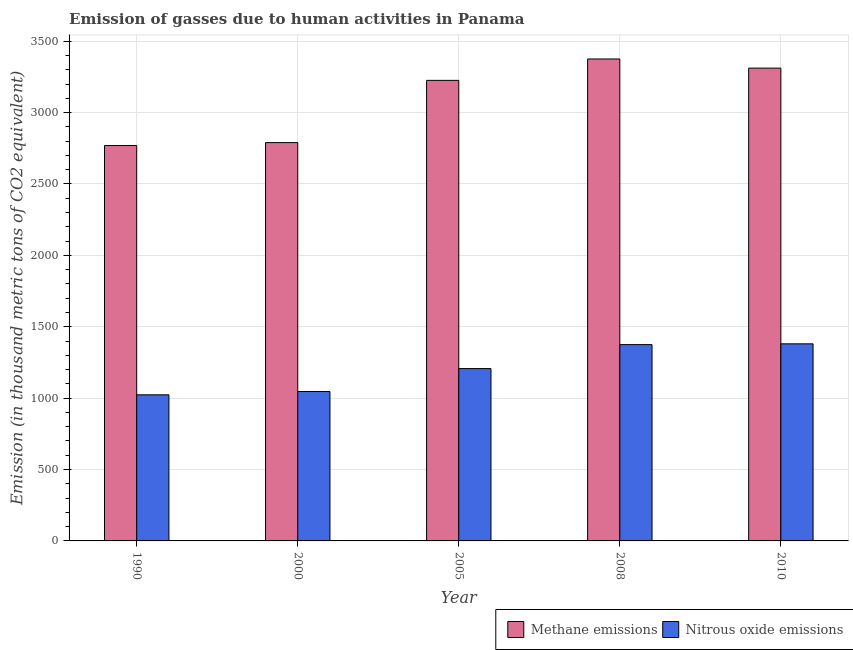What is the label of the 4th group of bars from the left?
Give a very brief answer. 2008. In how many cases, is the number of bars for a given year not equal to the number of legend labels?
Offer a terse response. 0. What is the amount of nitrous oxide emissions in 1990?
Provide a succinct answer. 1023.3. Across all years, what is the maximum amount of methane emissions?
Make the answer very short. 3375.7. Across all years, what is the minimum amount of methane emissions?
Offer a very short reply. 2769.4. In which year was the amount of methane emissions minimum?
Offer a very short reply. 1990. What is the total amount of nitrous oxide emissions in the graph?
Keep it short and to the point. 6032.2. What is the difference between the amount of nitrous oxide emissions in 2005 and that in 2010?
Your answer should be very brief. -173.3. What is the difference between the amount of methane emissions in 2000 and the amount of nitrous oxide emissions in 2010?
Your answer should be very brief. -521.7. What is the average amount of methane emissions per year?
Ensure brevity in your answer.  3094.5. In how many years, is the amount of methane emissions greater than 400 thousand metric tons?
Offer a terse response. 5. What is the ratio of the amount of nitrous oxide emissions in 2008 to that in 2010?
Your answer should be compact. 1. Is the amount of methane emissions in 2000 less than that in 2010?
Your answer should be very brief. Yes. Is the difference between the amount of methane emissions in 1990 and 2008 greater than the difference between the amount of nitrous oxide emissions in 1990 and 2008?
Offer a very short reply. No. What is the difference between the highest and the second highest amount of methane emissions?
Make the answer very short. 64.1. What is the difference between the highest and the lowest amount of nitrous oxide emissions?
Provide a short and direct response. 357.1. What does the 1st bar from the left in 2008 represents?
Ensure brevity in your answer.  Methane emissions. What does the 1st bar from the right in 2010 represents?
Offer a terse response. Nitrous oxide emissions. Are all the bars in the graph horizontal?
Give a very brief answer. No. How many years are there in the graph?
Provide a succinct answer. 5. What is the difference between two consecutive major ticks on the Y-axis?
Offer a terse response. 500. Are the values on the major ticks of Y-axis written in scientific E-notation?
Your answer should be compact. No. Does the graph contain any zero values?
Provide a short and direct response. No. Does the graph contain grids?
Make the answer very short. Yes. How many legend labels are there?
Keep it short and to the point. 2. How are the legend labels stacked?
Your response must be concise. Horizontal. What is the title of the graph?
Ensure brevity in your answer.  Emission of gasses due to human activities in Panama. What is the label or title of the Y-axis?
Offer a terse response. Emission (in thousand metric tons of CO2 equivalent). What is the Emission (in thousand metric tons of CO2 equivalent) of Methane emissions in 1990?
Offer a very short reply. 2769.4. What is the Emission (in thousand metric tons of CO2 equivalent) in Nitrous oxide emissions in 1990?
Offer a very short reply. 1023.3. What is the Emission (in thousand metric tons of CO2 equivalent) in Methane emissions in 2000?
Ensure brevity in your answer.  2789.9. What is the Emission (in thousand metric tons of CO2 equivalent) in Nitrous oxide emissions in 2000?
Offer a very short reply. 1046.4. What is the Emission (in thousand metric tons of CO2 equivalent) of Methane emissions in 2005?
Give a very brief answer. 3225.9. What is the Emission (in thousand metric tons of CO2 equivalent) of Nitrous oxide emissions in 2005?
Make the answer very short. 1207.1. What is the Emission (in thousand metric tons of CO2 equivalent) in Methane emissions in 2008?
Your answer should be very brief. 3375.7. What is the Emission (in thousand metric tons of CO2 equivalent) of Nitrous oxide emissions in 2008?
Provide a short and direct response. 1375. What is the Emission (in thousand metric tons of CO2 equivalent) of Methane emissions in 2010?
Provide a succinct answer. 3311.6. What is the Emission (in thousand metric tons of CO2 equivalent) of Nitrous oxide emissions in 2010?
Keep it short and to the point. 1380.4. Across all years, what is the maximum Emission (in thousand metric tons of CO2 equivalent) of Methane emissions?
Make the answer very short. 3375.7. Across all years, what is the maximum Emission (in thousand metric tons of CO2 equivalent) in Nitrous oxide emissions?
Your response must be concise. 1380.4. Across all years, what is the minimum Emission (in thousand metric tons of CO2 equivalent) of Methane emissions?
Your answer should be very brief. 2769.4. Across all years, what is the minimum Emission (in thousand metric tons of CO2 equivalent) in Nitrous oxide emissions?
Your answer should be very brief. 1023.3. What is the total Emission (in thousand metric tons of CO2 equivalent) in Methane emissions in the graph?
Ensure brevity in your answer.  1.55e+04. What is the total Emission (in thousand metric tons of CO2 equivalent) in Nitrous oxide emissions in the graph?
Offer a terse response. 6032.2. What is the difference between the Emission (in thousand metric tons of CO2 equivalent) of Methane emissions in 1990 and that in 2000?
Ensure brevity in your answer.  -20.5. What is the difference between the Emission (in thousand metric tons of CO2 equivalent) in Nitrous oxide emissions in 1990 and that in 2000?
Offer a terse response. -23.1. What is the difference between the Emission (in thousand metric tons of CO2 equivalent) of Methane emissions in 1990 and that in 2005?
Offer a terse response. -456.5. What is the difference between the Emission (in thousand metric tons of CO2 equivalent) of Nitrous oxide emissions in 1990 and that in 2005?
Provide a succinct answer. -183.8. What is the difference between the Emission (in thousand metric tons of CO2 equivalent) in Methane emissions in 1990 and that in 2008?
Give a very brief answer. -606.3. What is the difference between the Emission (in thousand metric tons of CO2 equivalent) of Nitrous oxide emissions in 1990 and that in 2008?
Your response must be concise. -351.7. What is the difference between the Emission (in thousand metric tons of CO2 equivalent) in Methane emissions in 1990 and that in 2010?
Offer a very short reply. -542.2. What is the difference between the Emission (in thousand metric tons of CO2 equivalent) in Nitrous oxide emissions in 1990 and that in 2010?
Provide a succinct answer. -357.1. What is the difference between the Emission (in thousand metric tons of CO2 equivalent) of Methane emissions in 2000 and that in 2005?
Provide a short and direct response. -436. What is the difference between the Emission (in thousand metric tons of CO2 equivalent) of Nitrous oxide emissions in 2000 and that in 2005?
Offer a very short reply. -160.7. What is the difference between the Emission (in thousand metric tons of CO2 equivalent) of Methane emissions in 2000 and that in 2008?
Your response must be concise. -585.8. What is the difference between the Emission (in thousand metric tons of CO2 equivalent) of Nitrous oxide emissions in 2000 and that in 2008?
Give a very brief answer. -328.6. What is the difference between the Emission (in thousand metric tons of CO2 equivalent) of Methane emissions in 2000 and that in 2010?
Offer a terse response. -521.7. What is the difference between the Emission (in thousand metric tons of CO2 equivalent) of Nitrous oxide emissions in 2000 and that in 2010?
Make the answer very short. -334. What is the difference between the Emission (in thousand metric tons of CO2 equivalent) in Methane emissions in 2005 and that in 2008?
Provide a short and direct response. -149.8. What is the difference between the Emission (in thousand metric tons of CO2 equivalent) of Nitrous oxide emissions in 2005 and that in 2008?
Offer a terse response. -167.9. What is the difference between the Emission (in thousand metric tons of CO2 equivalent) in Methane emissions in 2005 and that in 2010?
Make the answer very short. -85.7. What is the difference between the Emission (in thousand metric tons of CO2 equivalent) in Nitrous oxide emissions in 2005 and that in 2010?
Ensure brevity in your answer.  -173.3. What is the difference between the Emission (in thousand metric tons of CO2 equivalent) in Methane emissions in 2008 and that in 2010?
Provide a succinct answer. 64.1. What is the difference between the Emission (in thousand metric tons of CO2 equivalent) in Nitrous oxide emissions in 2008 and that in 2010?
Give a very brief answer. -5.4. What is the difference between the Emission (in thousand metric tons of CO2 equivalent) in Methane emissions in 1990 and the Emission (in thousand metric tons of CO2 equivalent) in Nitrous oxide emissions in 2000?
Your answer should be compact. 1723. What is the difference between the Emission (in thousand metric tons of CO2 equivalent) in Methane emissions in 1990 and the Emission (in thousand metric tons of CO2 equivalent) in Nitrous oxide emissions in 2005?
Provide a succinct answer. 1562.3. What is the difference between the Emission (in thousand metric tons of CO2 equivalent) of Methane emissions in 1990 and the Emission (in thousand metric tons of CO2 equivalent) of Nitrous oxide emissions in 2008?
Your answer should be compact. 1394.4. What is the difference between the Emission (in thousand metric tons of CO2 equivalent) of Methane emissions in 1990 and the Emission (in thousand metric tons of CO2 equivalent) of Nitrous oxide emissions in 2010?
Ensure brevity in your answer.  1389. What is the difference between the Emission (in thousand metric tons of CO2 equivalent) in Methane emissions in 2000 and the Emission (in thousand metric tons of CO2 equivalent) in Nitrous oxide emissions in 2005?
Offer a very short reply. 1582.8. What is the difference between the Emission (in thousand metric tons of CO2 equivalent) in Methane emissions in 2000 and the Emission (in thousand metric tons of CO2 equivalent) in Nitrous oxide emissions in 2008?
Offer a terse response. 1414.9. What is the difference between the Emission (in thousand metric tons of CO2 equivalent) of Methane emissions in 2000 and the Emission (in thousand metric tons of CO2 equivalent) of Nitrous oxide emissions in 2010?
Provide a short and direct response. 1409.5. What is the difference between the Emission (in thousand metric tons of CO2 equivalent) in Methane emissions in 2005 and the Emission (in thousand metric tons of CO2 equivalent) in Nitrous oxide emissions in 2008?
Provide a succinct answer. 1850.9. What is the difference between the Emission (in thousand metric tons of CO2 equivalent) of Methane emissions in 2005 and the Emission (in thousand metric tons of CO2 equivalent) of Nitrous oxide emissions in 2010?
Offer a terse response. 1845.5. What is the difference between the Emission (in thousand metric tons of CO2 equivalent) of Methane emissions in 2008 and the Emission (in thousand metric tons of CO2 equivalent) of Nitrous oxide emissions in 2010?
Your response must be concise. 1995.3. What is the average Emission (in thousand metric tons of CO2 equivalent) of Methane emissions per year?
Make the answer very short. 3094.5. What is the average Emission (in thousand metric tons of CO2 equivalent) in Nitrous oxide emissions per year?
Offer a terse response. 1206.44. In the year 1990, what is the difference between the Emission (in thousand metric tons of CO2 equivalent) in Methane emissions and Emission (in thousand metric tons of CO2 equivalent) in Nitrous oxide emissions?
Provide a succinct answer. 1746.1. In the year 2000, what is the difference between the Emission (in thousand metric tons of CO2 equivalent) of Methane emissions and Emission (in thousand metric tons of CO2 equivalent) of Nitrous oxide emissions?
Offer a terse response. 1743.5. In the year 2005, what is the difference between the Emission (in thousand metric tons of CO2 equivalent) in Methane emissions and Emission (in thousand metric tons of CO2 equivalent) in Nitrous oxide emissions?
Provide a succinct answer. 2018.8. In the year 2008, what is the difference between the Emission (in thousand metric tons of CO2 equivalent) of Methane emissions and Emission (in thousand metric tons of CO2 equivalent) of Nitrous oxide emissions?
Offer a very short reply. 2000.7. In the year 2010, what is the difference between the Emission (in thousand metric tons of CO2 equivalent) in Methane emissions and Emission (in thousand metric tons of CO2 equivalent) in Nitrous oxide emissions?
Make the answer very short. 1931.2. What is the ratio of the Emission (in thousand metric tons of CO2 equivalent) of Methane emissions in 1990 to that in 2000?
Provide a short and direct response. 0.99. What is the ratio of the Emission (in thousand metric tons of CO2 equivalent) of Nitrous oxide emissions in 1990 to that in 2000?
Give a very brief answer. 0.98. What is the ratio of the Emission (in thousand metric tons of CO2 equivalent) in Methane emissions in 1990 to that in 2005?
Provide a short and direct response. 0.86. What is the ratio of the Emission (in thousand metric tons of CO2 equivalent) in Nitrous oxide emissions in 1990 to that in 2005?
Keep it short and to the point. 0.85. What is the ratio of the Emission (in thousand metric tons of CO2 equivalent) in Methane emissions in 1990 to that in 2008?
Offer a very short reply. 0.82. What is the ratio of the Emission (in thousand metric tons of CO2 equivalent) in Nitrous oxide emissions in 1990 to that in 2008?
Ensure brevity in your answer.  0.74. What is the ratio of the Emission (in thousand metric tons of CO2 equivalent) of Methane emissions in 1990 to that in 2010?
Offer a very short reply. 0.84. What is the ratio of the Emission (in thousand metric tons of CO2 equivalent) of Nitrous oxide emissions in 1990 to that in 2010?
Provide a succinct answer. 0.74. What is the ratio of the Emission (in thousand metric tons of CO2 equivalent) of Methane emissions in 2000 to that in 2005?
Keep it short and to the point. 0.86. What is the ratio of the Emission (in thousand metric tons of CO2 equivalent) in Nitrous oxide emissions in 2000 to that in 2005?
Offer a very short reply. 0.87. What is the ratio of the Emission (in thousand metric tons of CO2 equivalent) in Methane emissions in 2000 to that in 2008?
Keep it short and to the point. 0.83. What is the ratio of the Emission (in thousand metric tons of CO2 equivalent) of Nitrous oxide emissions in 2000 to that in 2008?
Ensure brevity in your answer.  0.76. What is the ratio of the Emission (in thousand metric tons of CO2 equivalent) in Methane emissions in 2000 to that in 2010?
Your response must be concise. 0.84. What is the ratio of the Emission (in thousand metric tons of CO2 equivalent) of Nitrous oxide emissions in 2000 to that in 2010?
Provide a short and direct response. 0.76. What is the ratio of the Emission (in thousand metric tons of CO2 equivalent) in Methane emissions in 2005 to that in 2008?
Give a very brief answer. 0.96. What is the ratio of the Emission (in thousand metric tons of CO2 equivalent) in Nitrous oxide emissions in 2005 to that in 2008?
Make the answer very short. 0.88. What is the ratio of the Emission (in thousand metric tons of CO2 equivalent) of Methane emissions in 2005 to that in 2010?
Your response must be concise. 0.97. What is the ratio of the Emission (in thousand metric tons of CO2 equivalent) in Nitrous oxide emissions in 2005 to that in 2010?
Provide a succinct answer. 0.87. What is the ratio of the Emission (in thousand metric tons of CO2 equivalent) of Methane emissions in 2008 to that in 2010?
Give a very brief answer. 1.02. What is the difference between the highest and the second highest Emission (in thousand metric tons of CO2 equivalent) in Methane emissions?
Your answer should be compact. 64.1. What is the difference between the highest and the second highest Emission (in thousand metric tons of CO2 equivalent) in Nitrous oxide emissions?
Offer a very short reply. 5.4. What is the difference between the highest and the lowest Emission (in thousand metric tons of CO2 equivalent) of Methane emissions?
Keep it short and to the point. 606.3. What is the difference between the highest and the lowest Emission (in thousand metric tons of CO2 equivalent) in Nitrous oxide emissions?
Provide a short and direct response. 357.1. 